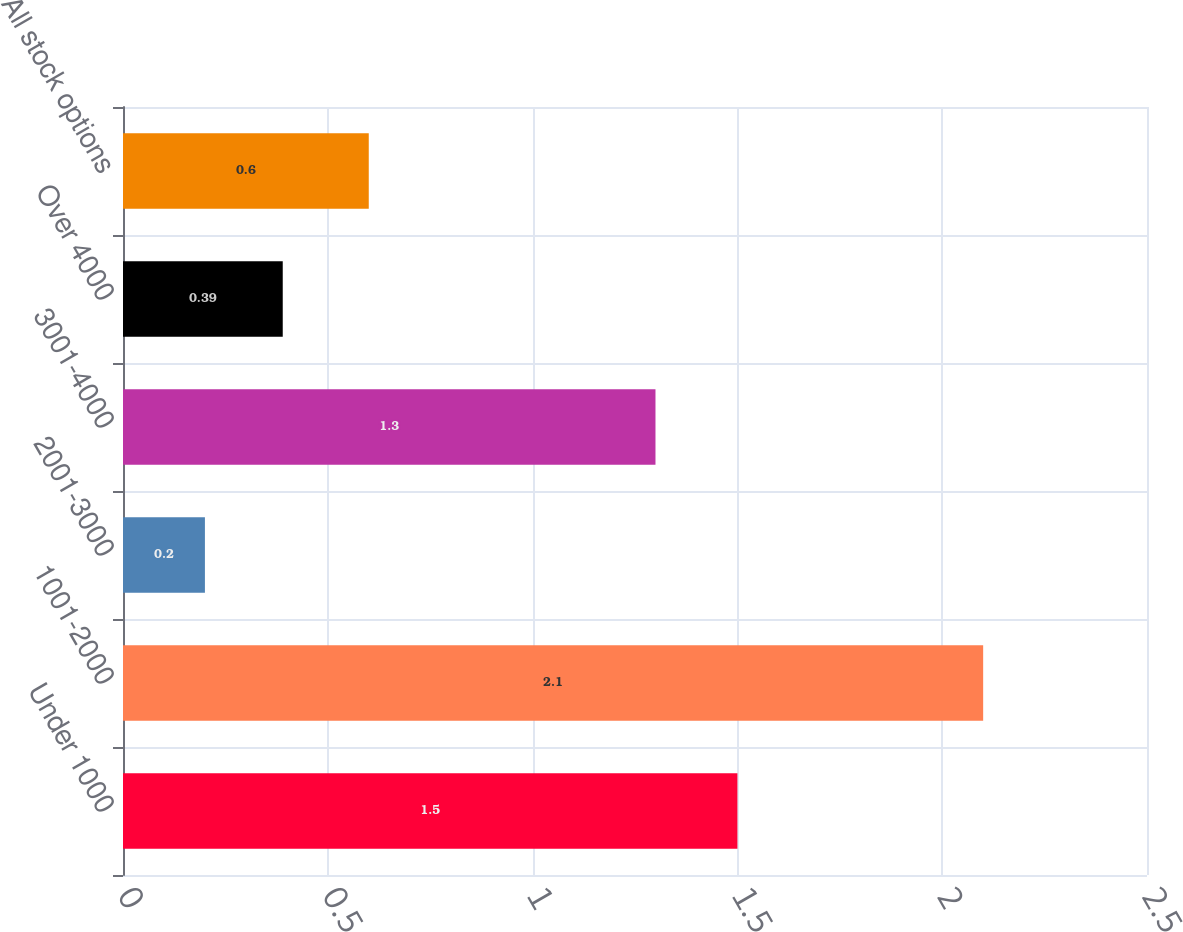Convert chart. <chart><loc_0><loc_0><loc_500><loc_500><bar_chart><fcel>Under 1000<fcel>1001-2000<fcel>2001-3000<fcel>3001-4000<fcel>Over 4000<fcel>All stock options<nl><fcel>1.5<fcel>2.1<fcel>0.2<fcel>1.3<fcel>0.39<fcel>0.6<nl></chart> 